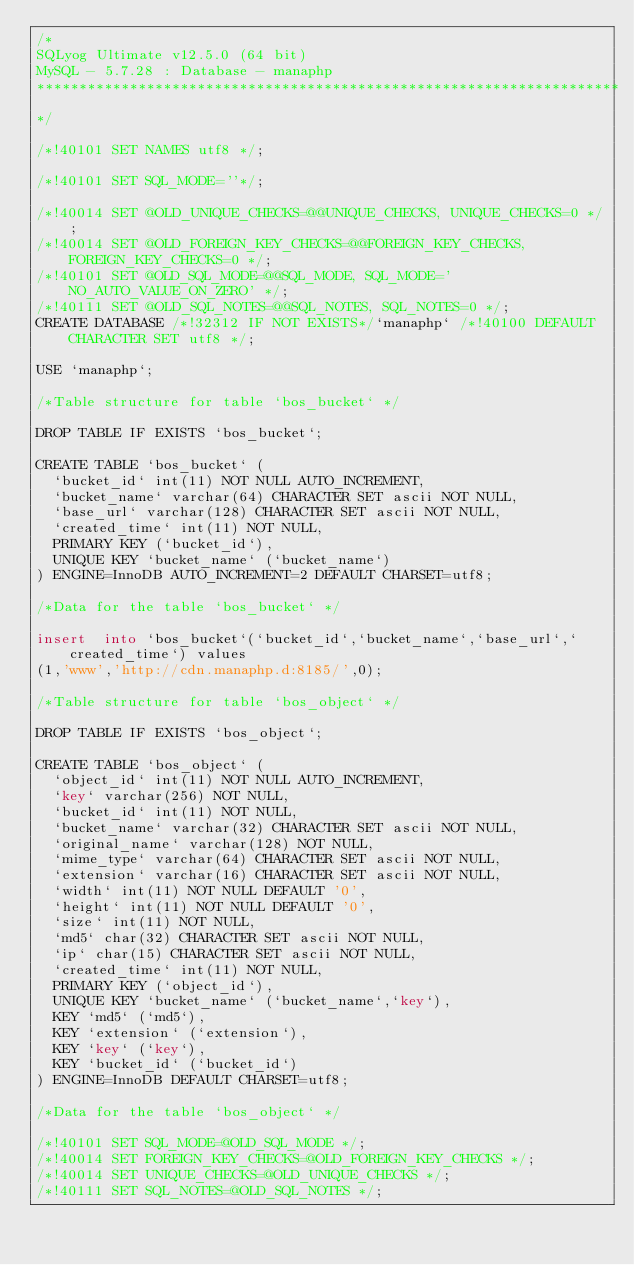<code> <loc_0><loc_0><loc_500><loc_500><_SQL_>/*
SQLyog Ultimate v12.5.0 (64 bit)
MySQL - 5.7.28 : Database - manaphp
*********************************************************************
*/

/*!40101 SET NAMES utf8 */;

/*!40101 SET SQL_MODE=''*/;

/*!40014 SET @OLD_UNIQUE_CHECKS=@@UNIQUE_CHECKS, UNIQUE_CHECKS=0 */;
/*!40014 SET @OLD_FOREIGN_KEY_CHECKS=@@FOREIGN_KEY_CHECKS, FOREIGN_KEY_CHECKS=0 */;
/*!40101 SET @OLD_SQL_MODE=@@SQL_MODE, SQL_MODE='NO_AUTO_VALUE_ON_ZERO' */;
/*!40111 SET @OLD_SQL_NOTES=@@SQL_NOTES, SQL_NOTES=0 */;
CREATE DATABASE /*!32312 IF NOT EXISTS*/`manaphp` /*!40100 DEFAULT CHARACTER SET utf8 */;

USE `manaphp`;

/*Table structure for table `bos_bucket` */

DROP TABLE IF EXISTS `bos_bucket`;

CREATE TABLE `bos_bucket` (
  `bucket_id` int(11) NOT NULL AUTO_INCREMENT,
  `bucket_name` varchar(64) CHARACTER SET ascii NOT NULL,
  `base_url` varchar(128) CHARACTER SET ascii NOT NULL,
  `created_time` int(11) NOT NULL,
  PRIMARY KEY (`bucket_id`),
  UNIQUE KEY `bucket_name` (`bucket_name`)
) ENGINE=InnoDB AUTO_INCREMENT=2 DEFAULT CHARSET=utf8;

/*Data for the table `bos_bucket` */

insert  into `bos_bucket`(`bucket_id`,`bucket_name`,`base_url`,`created_time`) values 
(1,'www','http://cdn.manaphp.d:8185/',0);

/*Table structure for table `bos_object` */

DROP TABLE IF EXISTS `bos_object`;

CREATE TABLE `bos_object` (
  `object_id` int(11) NOT NULL AUTO_INCREMENT,
  `key` varchar(256) NOT NULL,
  `bucket_id` int(11) NOT NULL,
  `bucket_name` varchar(32) CHARACTER SET ascii NOT NULL,
  `original_name` varchar(128) NOT NULL,
  `mime_type` varchar(64) CHARACTER SET ascii NOT NULL,
  `extension` varchar(16) CHARACTER SET ascii NOT NULL,
  `width` int(11) NOT NULL DEFAULT '0',
  `height` int(11) NOT NULL DEFAULT '0',
  `size` int(11) NOT NULL,
  `md5` char(32) CHARACTER SET ascii NOT NULL,
  `ip` char(15) CHARACTER SET ascii NOT NULL,
  `created_time` int(11) NOT NULL,
  PRIMARY KEY (`object_id`),
  UNIQUE KEY `bucket_name` (`bucket_name`,`key`),
  KEY `md5` (`md5`),
  KEY `extension` (`extension`),
  KEY `key` (`key`),
  KEY `bucket_id` (`bucket_id`)
) ENGINE=InnoDB DEFAULT CHARSET=utf8;

/*Data for the table `bos_object` */

/*!40101 SET SQL_MODE=@OLD_SQL_MODE */;
/*!40014 SET FOREIGN_KEY_CHECKS=@OLD_FOREIGN_KEY_CHECKS */;
/*!40014 SET UNIQUE_CHECKS=@OLD_UNIQUE_CHECKS */;
/*!40111 SET SQL_NOTES=@OLD_SQL_NOTES */;
</code> 